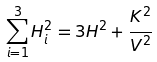Convert formula to latex. <formula><loc_0><loc_0><loc_500><loc_500>\sum _ { i = 1 } ^ { 3 } H _ { i } ^ { 2 } = 3 H ^ { 2 } + \frac { K ^ { 2 } } { V ^ { 2 } }</formula> 